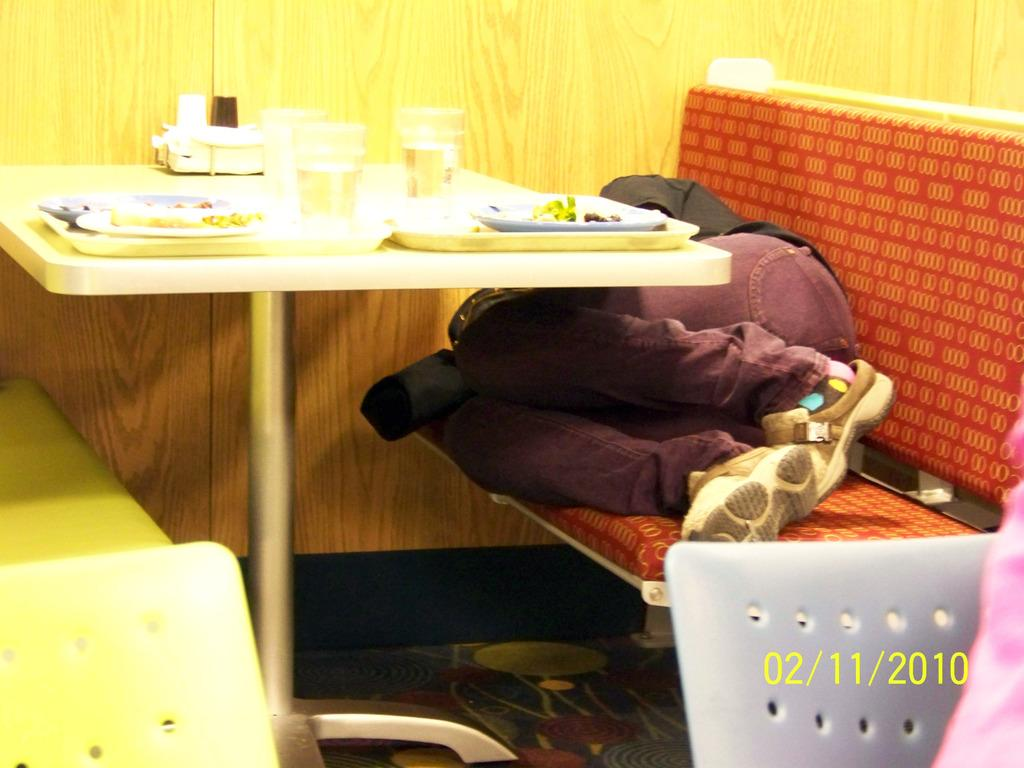What is the person in the image doing? The person is sleeping on a sofa. What is in front of the person? There is a table in front of the person. What can be found on the table? There are eatables and glasses of water on the table. What type of bear can be seen playing a whistle in the snow in the image? There is no bear, whistle, or snow present in the image. 